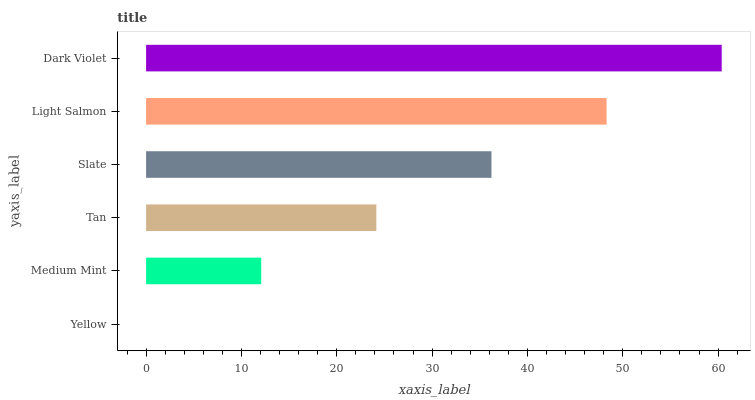Is Yellow the minimum?
Answer yes or no. Yes. Is Dark Violet the maximum?
Answer yes or no. Yes. Is Medium Mint the minimum?
Answer yes or no. No. Is Medium Mint the maximum?
Answer yes or no. No. Is Medium Mint greater than Yellow?
Answer yes or no. Yes. Is Yellow less than Medium Mint?
Answer yes or no. Yes. Is Yellow greater than Medium Mint?
Answer yes or no. No. Is Medium Mint less than Yellow?
Answer yes or no. No. Is Slate the high median?
Answer yes or no. Yes. Is Tan the low median?
Answer yes or no. Yes. Is Yellow the high median?
Answer yes or no. No. Is Yellow the low median?
Answer yes or no. No. 